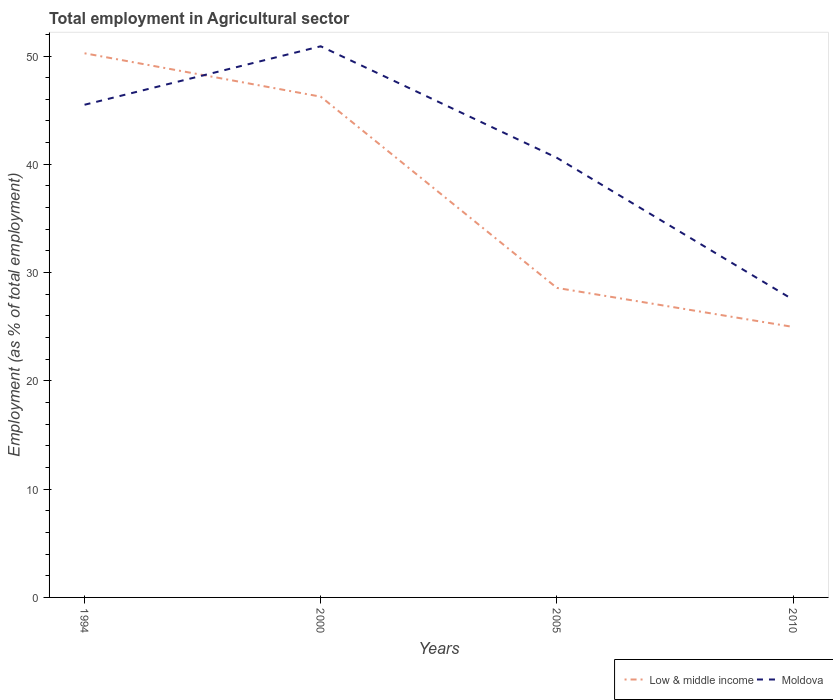How many different coloured lines are there?
Ensure brevity in your answer.  2. Across all years, what is the maximum employment in agricultural sector in Low & middle income?
Give a very brief answer. 24.98. In which year was the employment in agricultural sector in Moldova maximum?
Give a very brief answer. 2010. What is the total employment in agricultural sector in Moldova in the graph?
Offer a very short reply. 10.3. What is the difference between the highest and the second highest employment in agricultural sector in Moldova?
Provide a short and direct response. 23.4. What is the difference between the highest and the lowest employment in agricultural sector in Moldova?
Offer a very short reply. 2. What is the difference between two consecutive major ticks on the Y-axis?
Ensure brevity in your answer.  10. Does the graph contain grids?
Keep it short and to the point. No. Where does the legend appear in the graph?
Make the answer very short. Bottom right. What is the title of the graph?
Provide a short and direct response. Total employment in Agricultural sector. What is the label or title of the Y-axis?
Give a very brief answer. Employment (as % of total employment). What is the Employment (as % of total employment) in Low & middle income in 1994?
Provide a succinct answer. 50.25. What is the Employment (as % of total employment) in Moldova in 1994?
Give a very brief answer. 45.5. What is the Employment (as % of total employment) of Low & middle income in 2000?
Ensure brevity in your answer.  46.25. What is the Employment (as % of total employment) in Moldova in 2000?
Ensure brevity in your answer.  50.9. What is the Employment (as % of total employment) of Low & middle income in 2005?
Keep it short and to the point. 28.58. What is the Employment (as % of total employment) in Moldova in 2005?
Ensure brevity in your answer.  40.6. What is the Employment (as % of total employment) of Low & middle income in 2010?
Offer a very short reply. 24.98. Across all years, what is the maximum Employment (as % of total employment) of Low & middle income?
Ensure brevity in your answer.  50.25. Across all years, what is the maximum Employment (as % of total employment) in Moldova?
Your answer should be very brief. 50.9. Across all years, what is the minimum Employment (as % of total employment) of Low & middle income?
Offer a terse response. 24.98. What is the total Employment (as % of total employment) in Low & middle income in the graph?
Your answer should be very brief. 150.07. What is the total Employment (as % of total employment) in Moldova in the graph?
Your answer should be compact. 164.5. What is the difference between the Employment (as % of total employment) in Low & middle income in 1994 and that in 2000?
Keep it short and to the point. 4.01. What is the difference between the Employment (as % of total employment) of Low & middle income in 1994 and that in 2005?
Provide a succinct answer. 21.67. What is the difference between the Employment (as % of total employment) of Low & middle income in 1994 and that in 2010?
Provide a short and direct response. 25.27. What is the difference between the Employment (as % of total employment) of Moldova in 1994 and that in 2010?
Keep it short and to the point. 18. What is the difference between the Employment (as % of total employment) of Low & middle income in 2000 and that in 2005?
Provide a succinct answer. 17.66. What is the difference between the Employment (as % of total employment) of Moldova in 2000 and that in 2005?
Offer a terse response. 10.3. What is the difference between the Employment (as % of total employment) in Low & middle income in 2000 and that in 2010?
Ensure brevity in your answer.  21.27. What is the difference between the Employment (as % of total employment) in Moldova in 2000 and that in 2010?
Offer a terse response. 23.4. What is the difference between the Employment (as % of total employment) in Low & middle income in 2005 and that in 2010?
Your answer should be very brief. 3.6. What is the difference between the Employment (as % of total employment) of Low & middle income in 1994 and the Employment (as % of total employment) of Moldova in 2000?
Offer a very short reply. -0.65. What is the difference between the Employment (as % of total employment) of Low & middle income in 1994 and the Employment (as % of total employment) of Moldova in 2005?
Offer a terse response. 9.65. What is the difference between the Employment (as % of total employment) in Low & middle income in 1994 and the Employment (as % of total employment) in Moldova in 2010?
Provide a succinct answer. 22.75. What is the difference between the Employment (as % of total employment) of Low & middle income in 2000 and the Employment (as % of total employment) of Moldova in 2005?
Offer a terse response. 5.65. What is the difference between the Employment (as % of total employment) in Low & middle income in 2000 and the Employment (as % of total employment) in Moldova in 2010?
Your answer should be very brief. 18.75. What is the difference between the Employment (as % of total employment) in Low & middle income in 2005 and the Employment (as % of total employment) in Moldova in 2010?
Your response must be concise. 1.08. What is the average Employment (as % of total employment) in Low & middle income per year?
Keep it short and to the point. 37.52. What is the average Employment (as % of total employment) in Moldova per year?
Provide a short and direct response. 41.12. In the year 1994, what is the difference between the Employment (as % of total employment) of Low & middle income and Employment (as % of total employment) of Moldova?
Ensure brevity in your answer.  4.75. In the year 2000, what is the difference between the Employment (as % of total employment) in Low & middle income and Employment (as % of total employment) in Moldova?
Offer a terse response. -4.65. In the year 2005, what is the difference between the Employment (as % of total employment) in Low & middle income and Employment (as % of total employment) in Moldova?
Make the answer very short. -12.02. In the year 2010, what is the difference between the Employment (as % of total employment) in Low & middle income and Employment (as % of total employment) in Moldova?
Give a very brief answer. -2.52. What is the ratio of the Employment (as % of total employment) of Low & middle income in 1994 to that in 2000?
Give a very brief answer. 1.09. What is the ratio of the Employment (as % of total employment) in Moldova in 1994 to that in 2000?
Offer a terse response. 0.89. What is the ratio of the Employment (as % of total employment) in Low & middle income in 1994 to that in 2005?
Your response must be concise. 1.76. What is the ratio of the Employment (as % of total employment) in Moldova in 1994 to that in 2005?
Offer a very short reply. 1.12. What is the ratio of the Employment (as % of total employment) in Low & middle income in 1994 to that in 2010?
Provide a succinct answer. 2.01. What is the ratio of the Employment (as % of total employment) in Moldova in 1994 to that in 2010?
Offer a terse response. 1.65. What is the ratio of the Employment (as % of total employment) of Low & middle income in 2000 to that in 2005?
Provide a succinct answer. 1.62. What is the ratio of the Employment (as % of total employment) in Moldova in 2000 to that in 2005?
Provide a short and direct response. 1.25. What is the ratio of the Employment (as % of total employment) of Low & middle income in 2000 to that in 2010?
Keep it short and to the point. 1.85. What is the ratio of the Employment (as % of total employment) of Moldova in 2000 to that in 2010?
Make the answer very short. 1.85. What is the ratio of the Employment (as % of total employment) in Low & middle income in 2005 to that in 2010?
Your answer should be very brief. 1.14. What is the ratio of the Employment (as % of total employment) in Moldova in 2005 to that in 2010?
Ensure brevity in your answer.  1.48. What is the difference between the highest and the second highest Employment (as % of total employment) of Low & middle income?
Your answer should be compact. 4.01. What is the difference between the highest and the lowest Employment (as % of total employment) in Low & middle income?
Provide a succinct answer. 25.27. What is the difference between the highest and the lowest Employment (as % of total employment) of Moldova?
Keep it short and to the point. 23.4. 